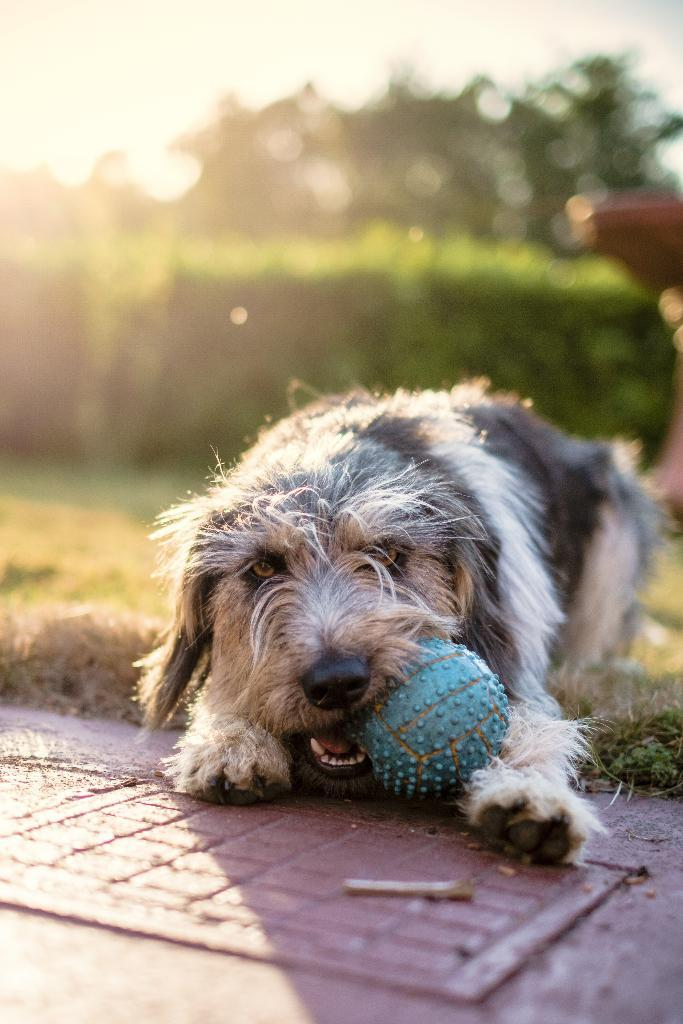What animal can be seen in the image? There is a dog in the image. What is the dog holding in its mouth? The dog is holding a ball. What type of surface is the dog standing on? There is grass on the ground in the image. Can you describe the background of the image? The background of the image is blurred. What year is depicted in the image? The image does not depict a specific year; it is a photograph of a dog holding a ball on grass. 